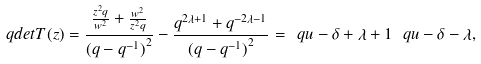<formula> <loc_0><loc_0><loc_500><loc_500>\ q d e t T ( z ) = \frac { \frac { z ^ { 2 } q } { w ^ { 2 } } + \frac { w ^ { 2 } } { z ^ { 2 } q } } { { ( q - q ^ { - 1 } ) } ^ { 2 } } - \frac { q ^ { 2 \lambda + 1 } + q ^ { - 2 \lambda - 1 } } { { ( q - q ^ { - 1 } ) } ^ { 2 } } = \ q { u - \delta + \lambda + 1 } \, \ q { u - \delta - \lambda } ,</formula> 